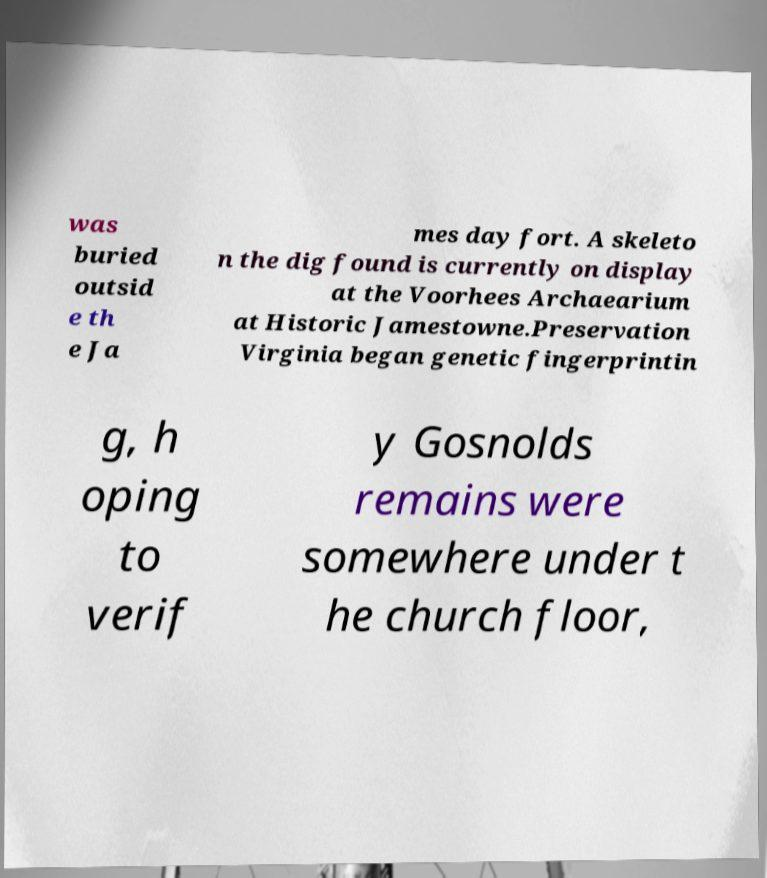Please identify and transcribe the text found in this image. was buried outsid e th e Ja mes day fort. A skeleto n the dig found is currently on display at the Voorhees Archaearium at Historic Jamestowne.Preservation Virginia began genetic fingerprintin g, h oping to verif y Gosnolds remains were somewhere under t he church floor, 